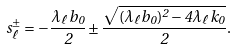<formula> <loc_0><loc_0><loc_500><loc_500>s _ { \ell } ^ { \pm } = - \frac { \lambda _ { \ell } b _ { 0 } } { 2 } \pm \frac { \sqrt { ( \lambda _ { \ell } b _ { 0 } ) ^ { 2 } - 4 \lambda _ { \ell } k _ { 0 } } } { 2 } .</formula> 